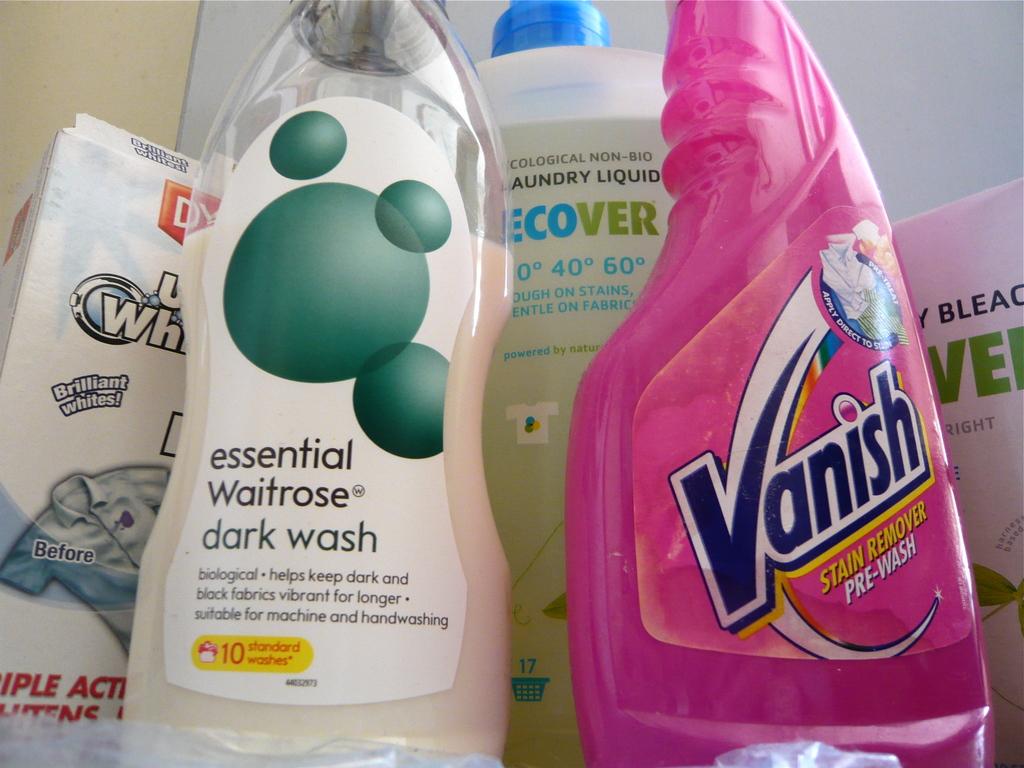What brand is the pre-wash?
Your answer should be compact. Vanish. What brand is the dark wash?
Ensure brevity in your answer.  Essential waitrose. 